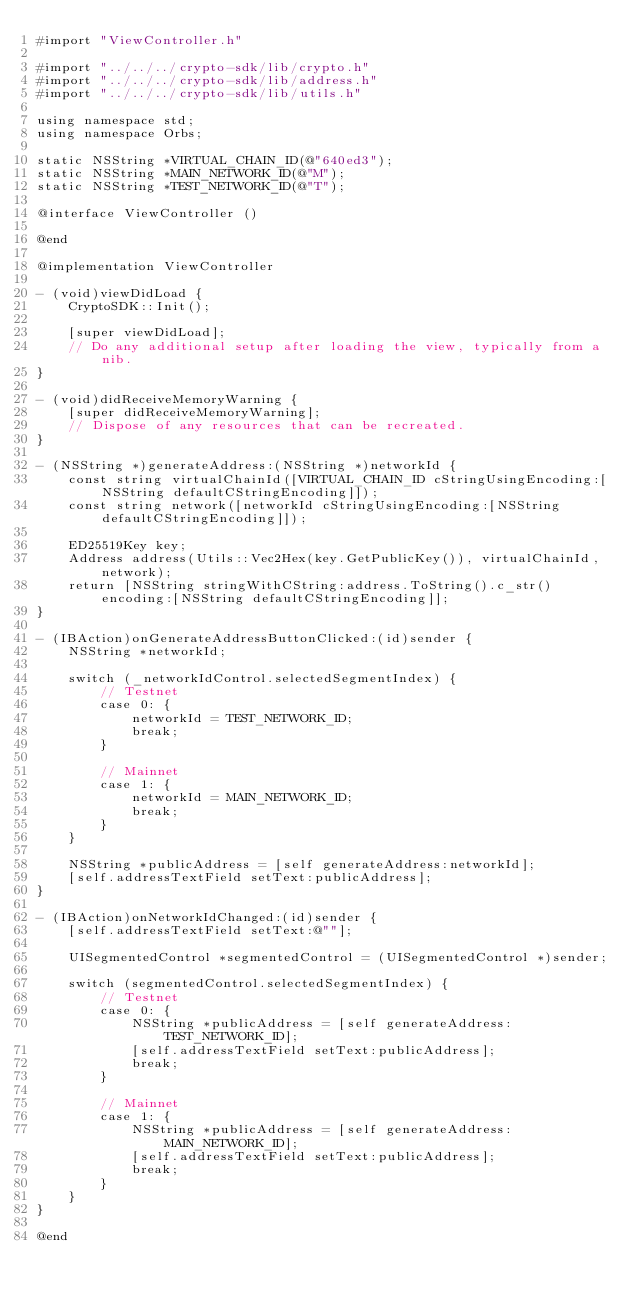<code> <loc_0><loc_0><loc_500><loc_500><_ObjectiveC_>#import "ViewController.h"

#import "../../../crypto-sdk/lib/crypto.h"
#import "../../../crypto-sdk/lib/address.h"
#import "../../../crypto-sdk/lib/utils.h"

using namespace std;
using namespace Orbs;

static NSString *VIRTUAL_CHAIN_ID(@"640ed3");
static NSString *MAIN_NETWORK_ID(@"M");
static NSString *TEST_NETWORK_ID(@"T");

@interface ViewController ()

@end

@implementation ViewController

- (void)viewDidLoad {
    CryptoSDK::Init();
    
    [super viewDidLoad];
    // Do any additional setup after loading the view, typically from a nib.
}

- (void)didReceiveMemoryWarning {
    [super didReceiveMemoryWarning];
    // Dispose of any resources that can be recreated.
}

- (NSString *)generateAddress:(NSString *)networkId {
    const string virtualChainId([VIRTUAL_CHAIN_ID cStringUsingEncoding:[NSString defaultCStringEncoding]]);
    const string network([networkId cStringUsingEncoding:[NSString defaultCStringEncoding]]);
    
    ED25519Key key;
    Address address(Utils::Vec2Hex(key.GetPublicKey()), virtualChainId, network);
    return [NSString stringWithCString:address.ToString().c_str() encoding:[NSString defaultCStringEncoding]];
}

- (IBAction)onGenerateAddressButtonClicked:(id)sender {
    NSString *networkId;
    
    switch (_networkIdControl.selectedSegmentIndex) {
        // Testnet
        case 0: {
            networkId = TEST_NETWORK_ID;
            break;
        }
            
        // Mainnet
        case 1: {
            networkId = MAIN_NETWORK_ID;
            break;
        }
    }
    
    NSString *publicAddress = [self generateAddress:networkId];
    [self.addressTextField setText:publicAddress];
}

- (IBAction)onNetworkIdChanged:(id)sender {
    [self.addressTextField setText:@""];
    
    UISegmentedControl *segmentedControl = (UISegmentedControl *)sender;
    
    switch (segmentedControl.selectedSegmentIndex) {
        // Testnet
        case 0: {
            NSString *publicAddress = [self generateAddress:TEST_NETWORK_ID];
            [self.addressTextField setText:publicAddress];
            break;
        }
            
        // Mainnet
        case 1: {
            NSString *publicAddress = [self generateAddress:MAIN_NETWORK_ID];
            [self.addressTextField setText:publicAddress];
            break;
        }
    }
}

@end
</code> 